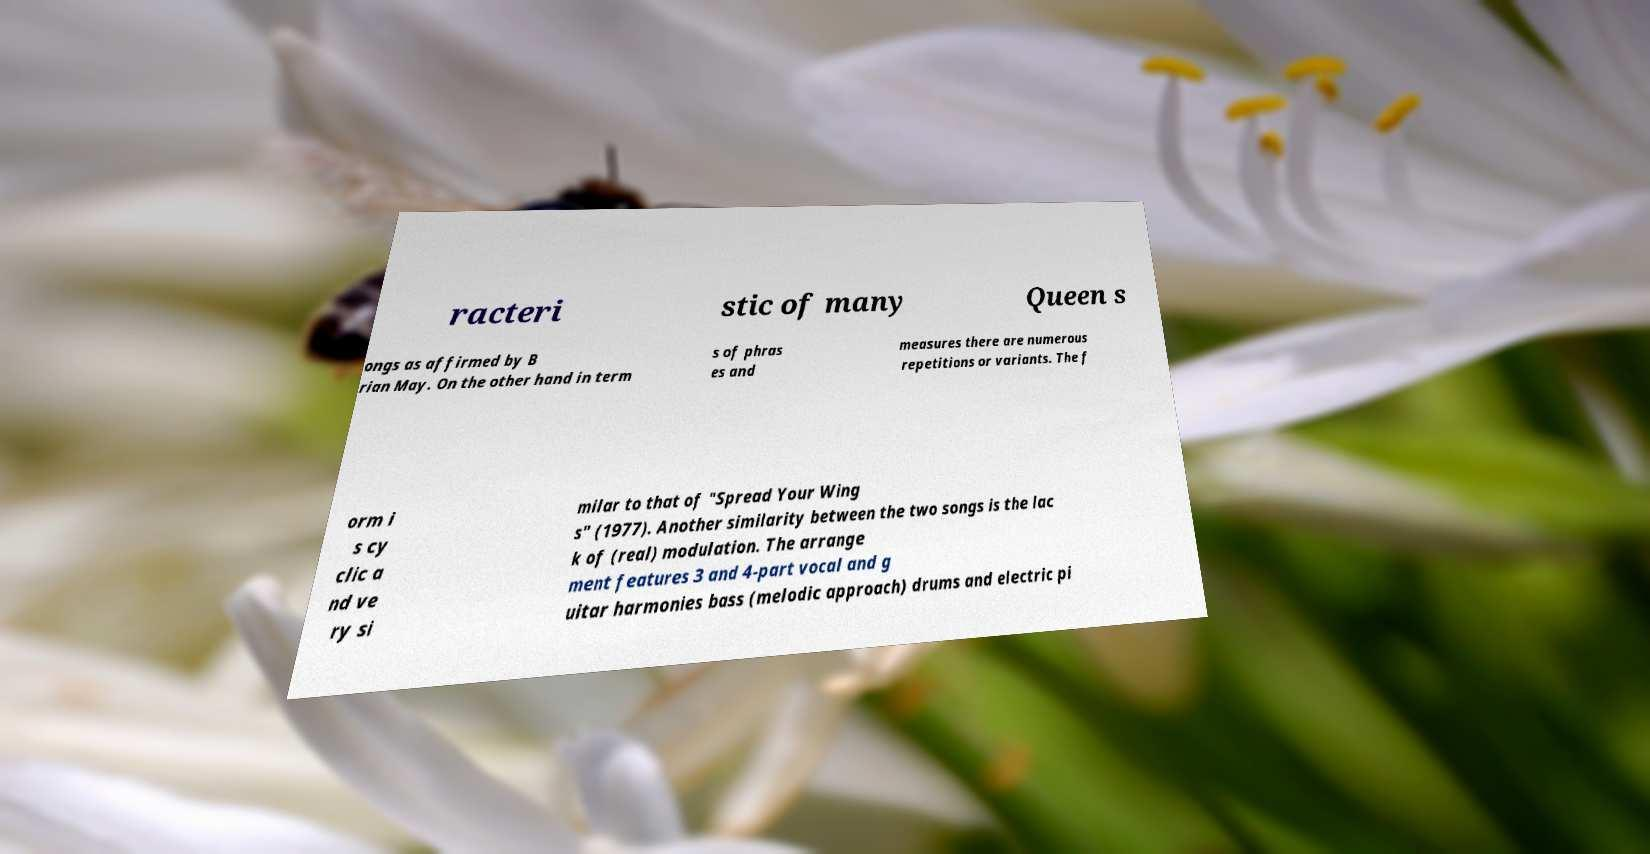Could you assist in decoding the text presented in this image and type it out clearly? racteri stic of many Queen s ongs as affirmed by B rian May. On the other hand in term s of phras es and measures there are numerous repetitions or variants. The f orm i s cy clic a nd ve ry si milar to that of "Spread Your Wing s" (1977). Another similarity between the two songs is the lac k of (real) modulation. The arrange ment features 3 and 4-part vocal and g uitar harmonies bass (melodic approach) drums and electric pi 